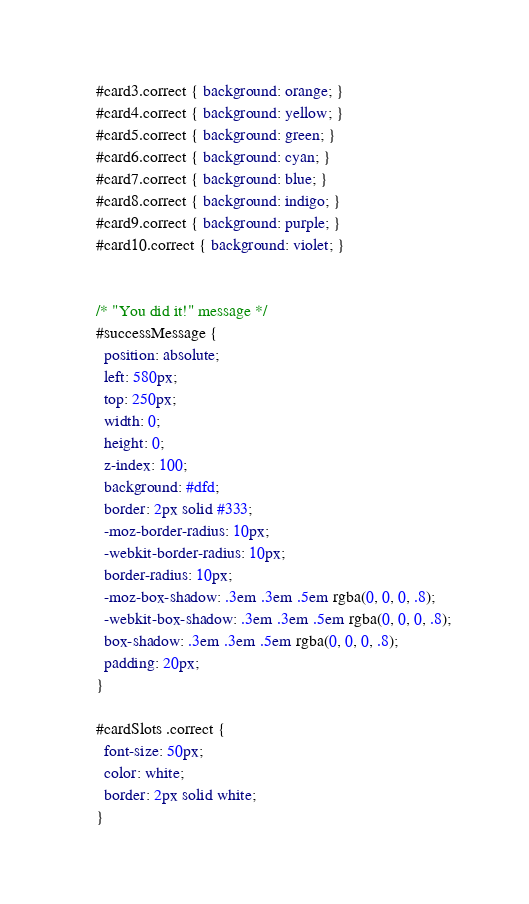<code> <loc_0><loc_0><loc_500><loc_500><_CSS_>#card3.correct { background: orange; }
#card4.correct { background: yellow; }
#card5.correct { background: green; }
#card6.correct { background: cyan; }
#card7.correct { background: blue; }
#card8.correct { background: indigo; }
#card9.correct { background: purple; }
#card10.correct { background: violet; }


/* "You did it!" message */
#successMessage {
  position: absolute;
  left: 580px;
  top: 250px;
  width: 0;
  height: 0;
  z-index: 100;
  background: #dfd;
  border: 2px solid #333;
  -moz-border-radius: 10px;
  -webkit-border-radius: 10px;
  border-radius: 10px;
  -moz-box-shadow: .3em .3em .5em rgba(0, 0, 0, .8);
  -webkit-box-shadow: .3em .3em .5em rgba(0, 0, 0, .8);
  box-shadow: .3em .3em .5em rgba(0, 0, 0, .8);
  padding: 20px;
}

#cardSlots .correct {
  font-size: 50px;
  color: white;
  border: 2px solid white;
}</code> 